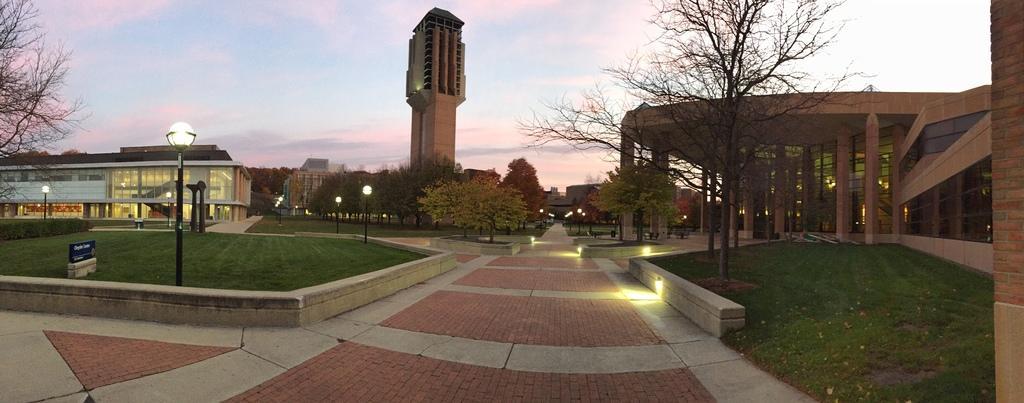Describe this image in one or two sentences. In this image I can see few poles, few lights, few trees, number of buildings, grass and in the background I can see the sky. 